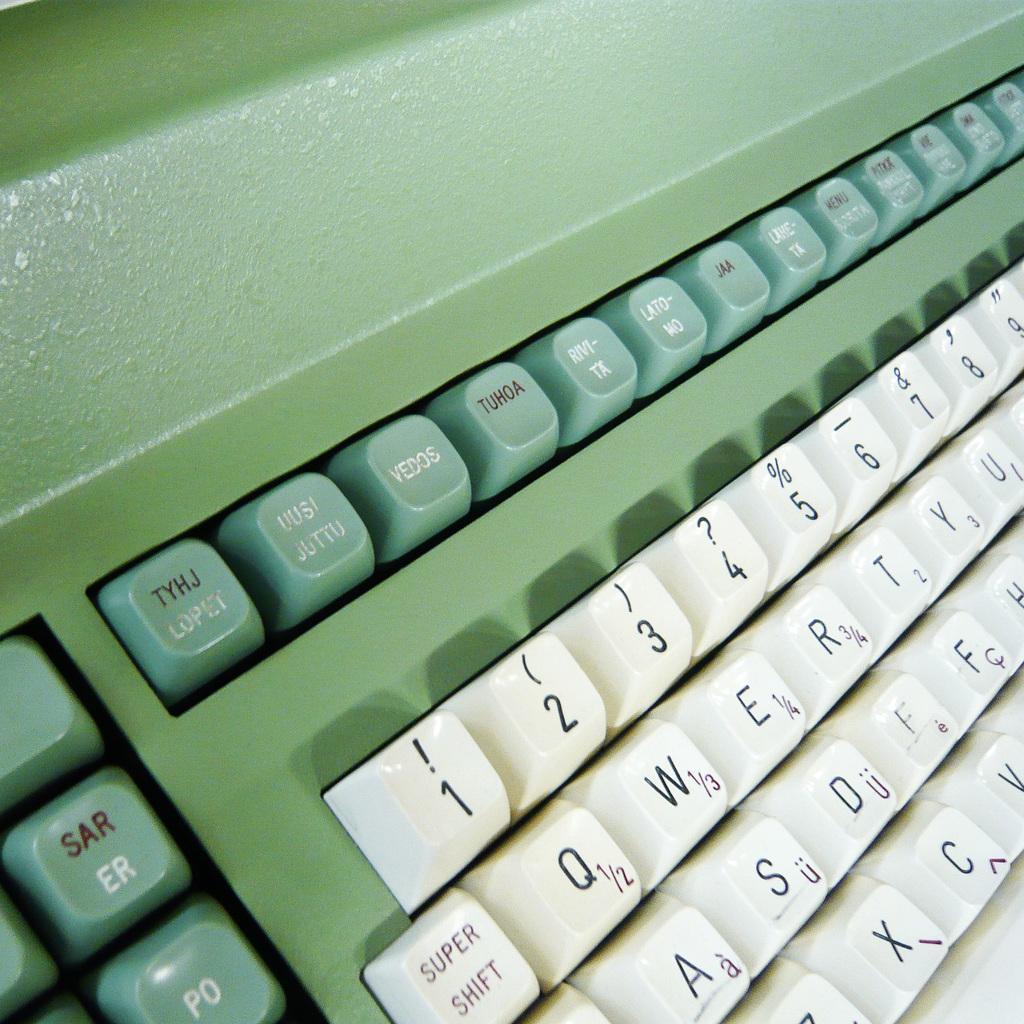<image>
Render a clear and concise summary of the photo. A green and white keyboard has a key that says TYHJ along the top row. 